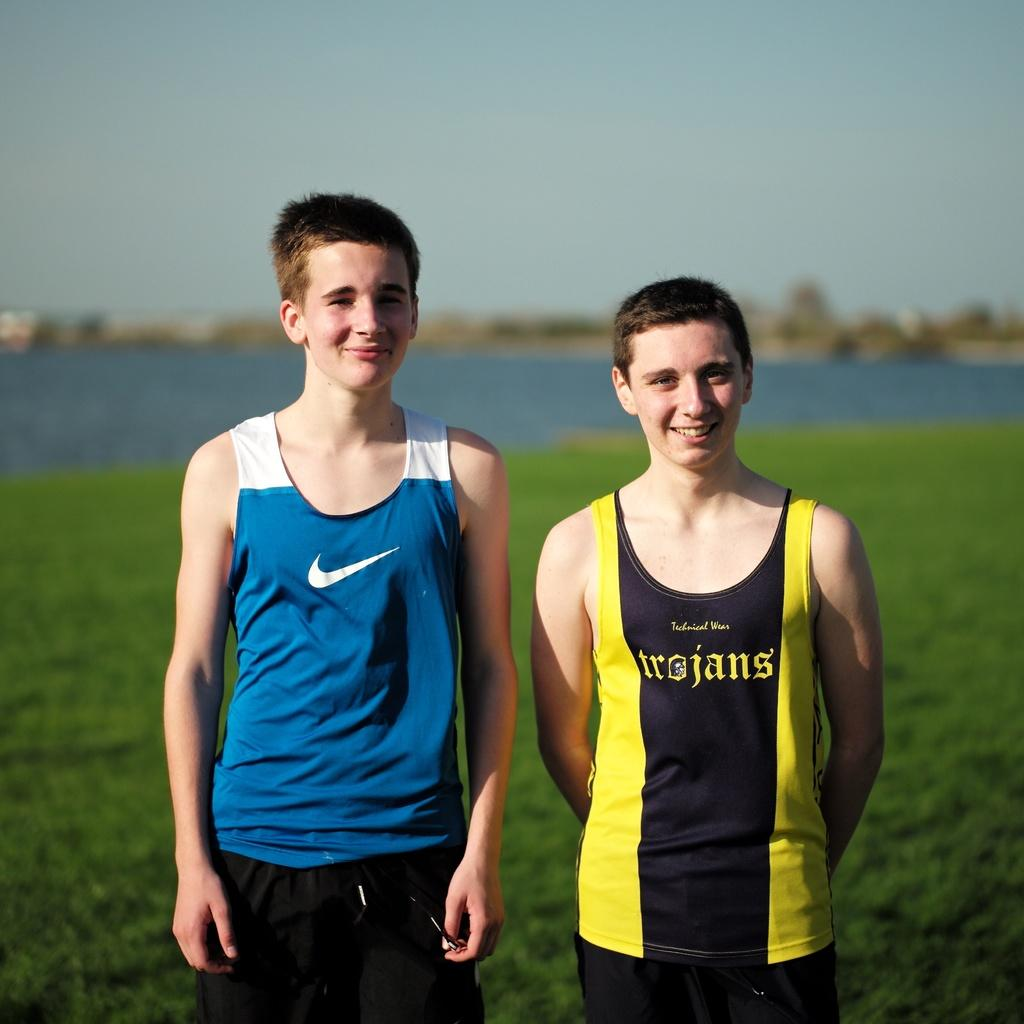Provide a one-sentence caption for the provided image. Two boys standing on grass, one with a blue tank top with a white Nike swoosh and the other with a yellow and black tank top that says trojans. 